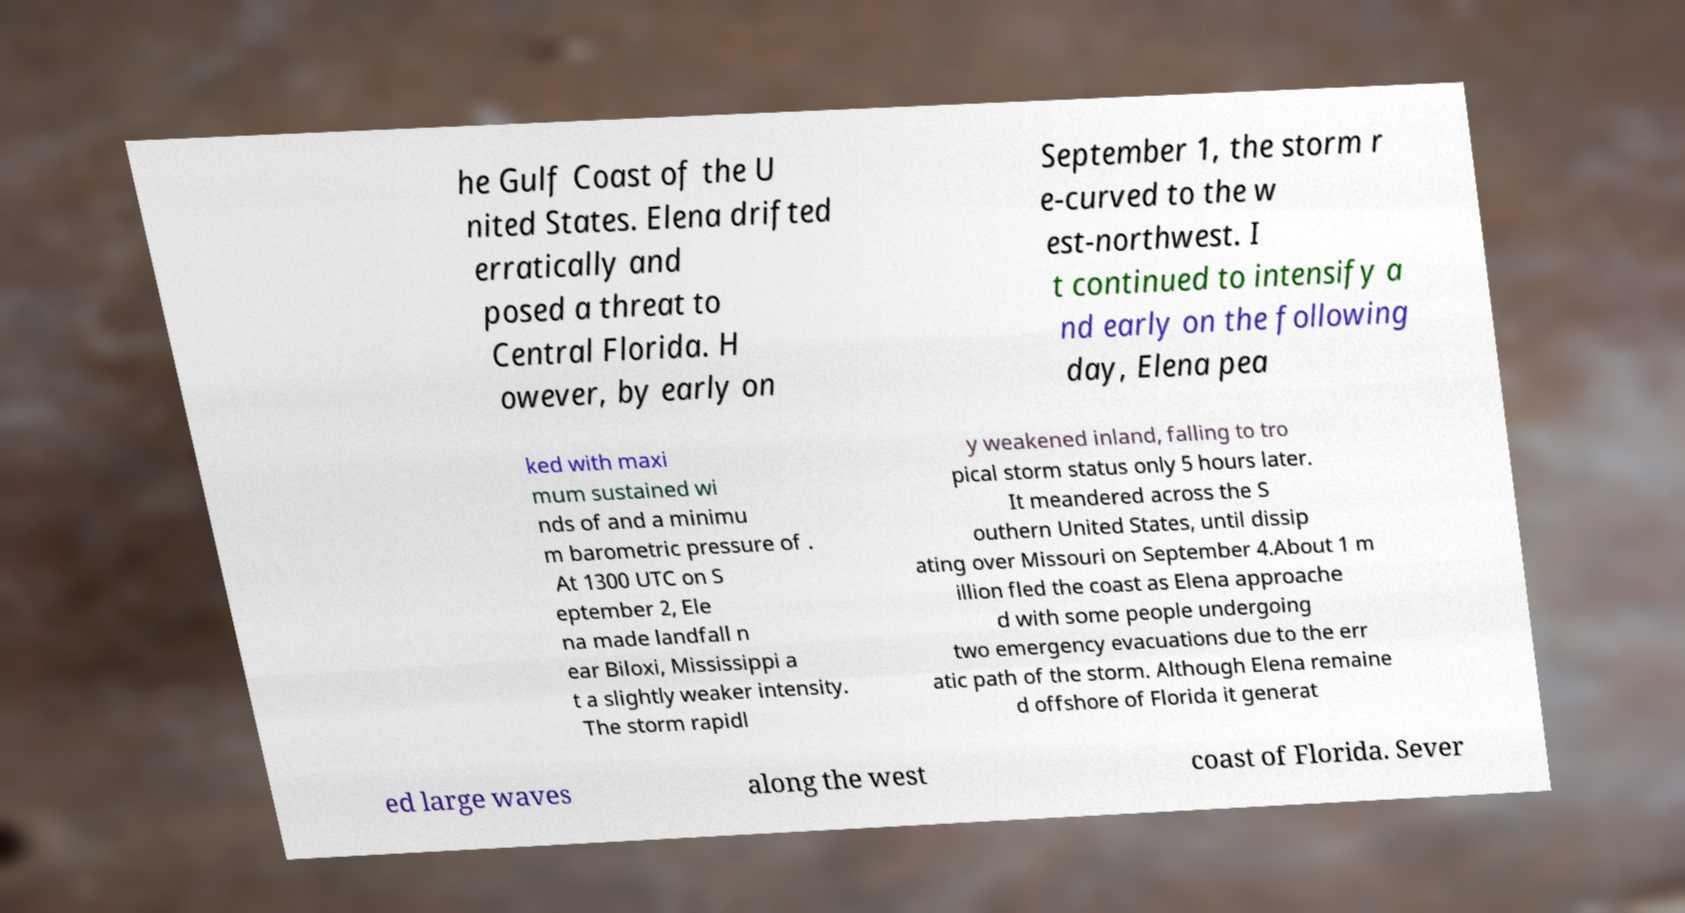Could you extract and type out the text from this image? he Gulf Coast of the U nited States. Elena drifted erratically and posed a threat to Central Florida. H owever, by early on September 1, the storm r e-curved to the w est-northwest. I t continued to intensify a nd early on the following day, Elena pea ked with maxi mum sustained wi nds of and a minimu m barometric pressure of . At 1300 UTC on S eptember 2, Ele na made landfall n ear Biloxi, Mississippi a t a slightly weaker intensity. The storm rapidl y weakened inland, falling to tro pical storm status only 5 hours later. It meandered across the S outhern United States, until dissip ating over Missouri on September 4.About 1 m illion fled the coast as Elena approache d with some people undergoing two emergency evacuations due to the err atic path of the storm. Although Elena remaine d offshore of Florida it generat ed large waves along the west coast of Florida. Sever 